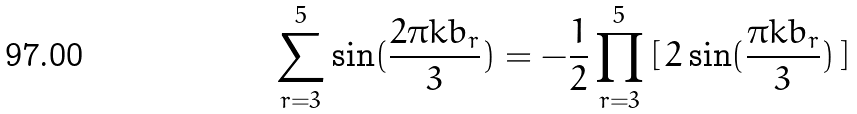Convert formula to latex. <formula><loc_0><loc_0><loc_500><loc_500>\sum _ { r = 3 } ^ { 5 } \sin ( \frac { 2 \pi k b _ { r } } { 3 } ) = - \frac { 1 } { 2 } \prod ^ { 5 } _ { r = 3 } \, [ \, 2 \sin ( \frac { \pi k b _ { r } } { 3 } ) \, ]</formula> 